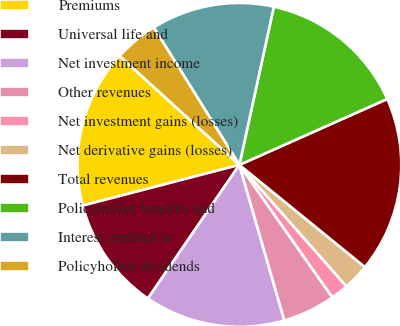Convert chart to OTSL. <chart><loc_0><loc_0><loc_500><loc_500><pie_chart><fcel>Premiums<fcel>Universal life and<fcel>Net investment income<fcel>Other revenues<fcel>Net investment gains (losses)<fcel>Net derivative gains (losses)<fcel>Total revenues<fcel>Policyholder benefits and<fcel>Interest credited to<fcel>Policyholder dividends<nl><fcel>15.79%<fcel>11.4%<fcel>14.03%<fcel>5.26%<fcel>1.76%<fcel>2.63%<fcel>17.54%<fcel>14.91%<fcel>12.28%<fcel>4.39%<nl></chart> 